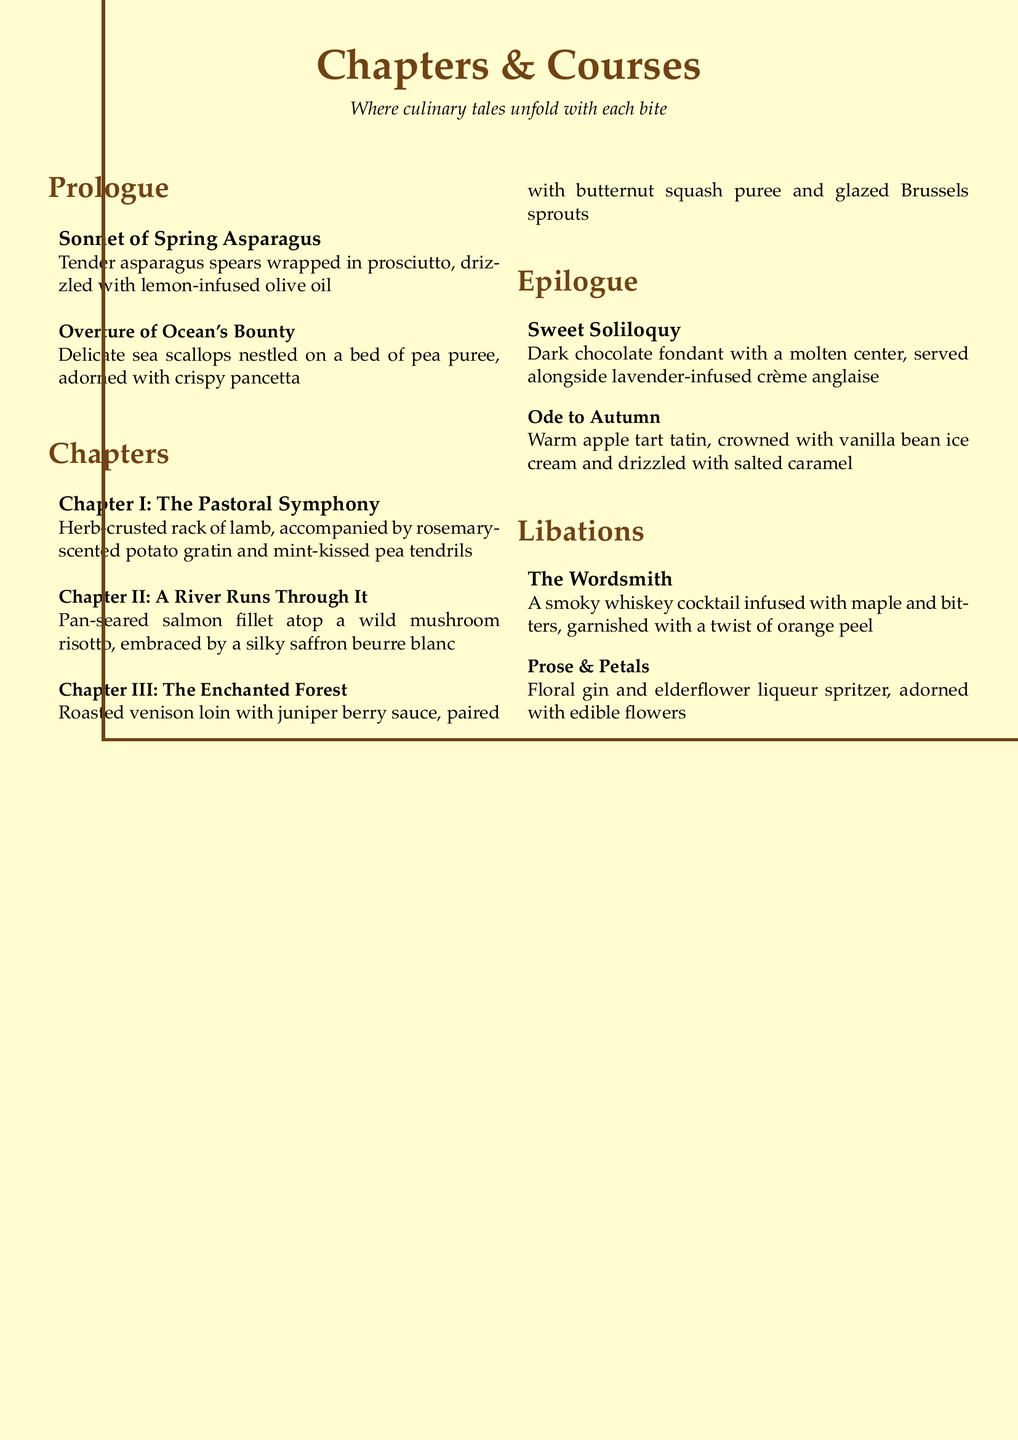What are the two appetizers listed? The appetizers are presented as the "Prologue" section, featuring two items: Sonnet of Spring Asparagus and Overture of Ocean's Bounty.
Answer: Sonnet of Spring Asparagus, Overture of Ocean's Bounty How many main courses are offered? The main courses are categorized as "Chapters" in the document, listing three distinct dishes under this heading.
Answer: 3 What is the title of Chapter II? The title of Chapter II is specifically mentioned in the document, which is dedicated to the second main course.
Answer: A River Runs Through It Which dessert features dark chocolate? One of the desserts in the "Epilogue" section is described with specific reference to dark chocolate.
Answer: Sweet Soliloquy What beverage contains floral elements? The drinks section lists a cocktail that includes floral notes, specifically mentioning both gin and elderflower liqueur.
Answer: Prose & Petals 